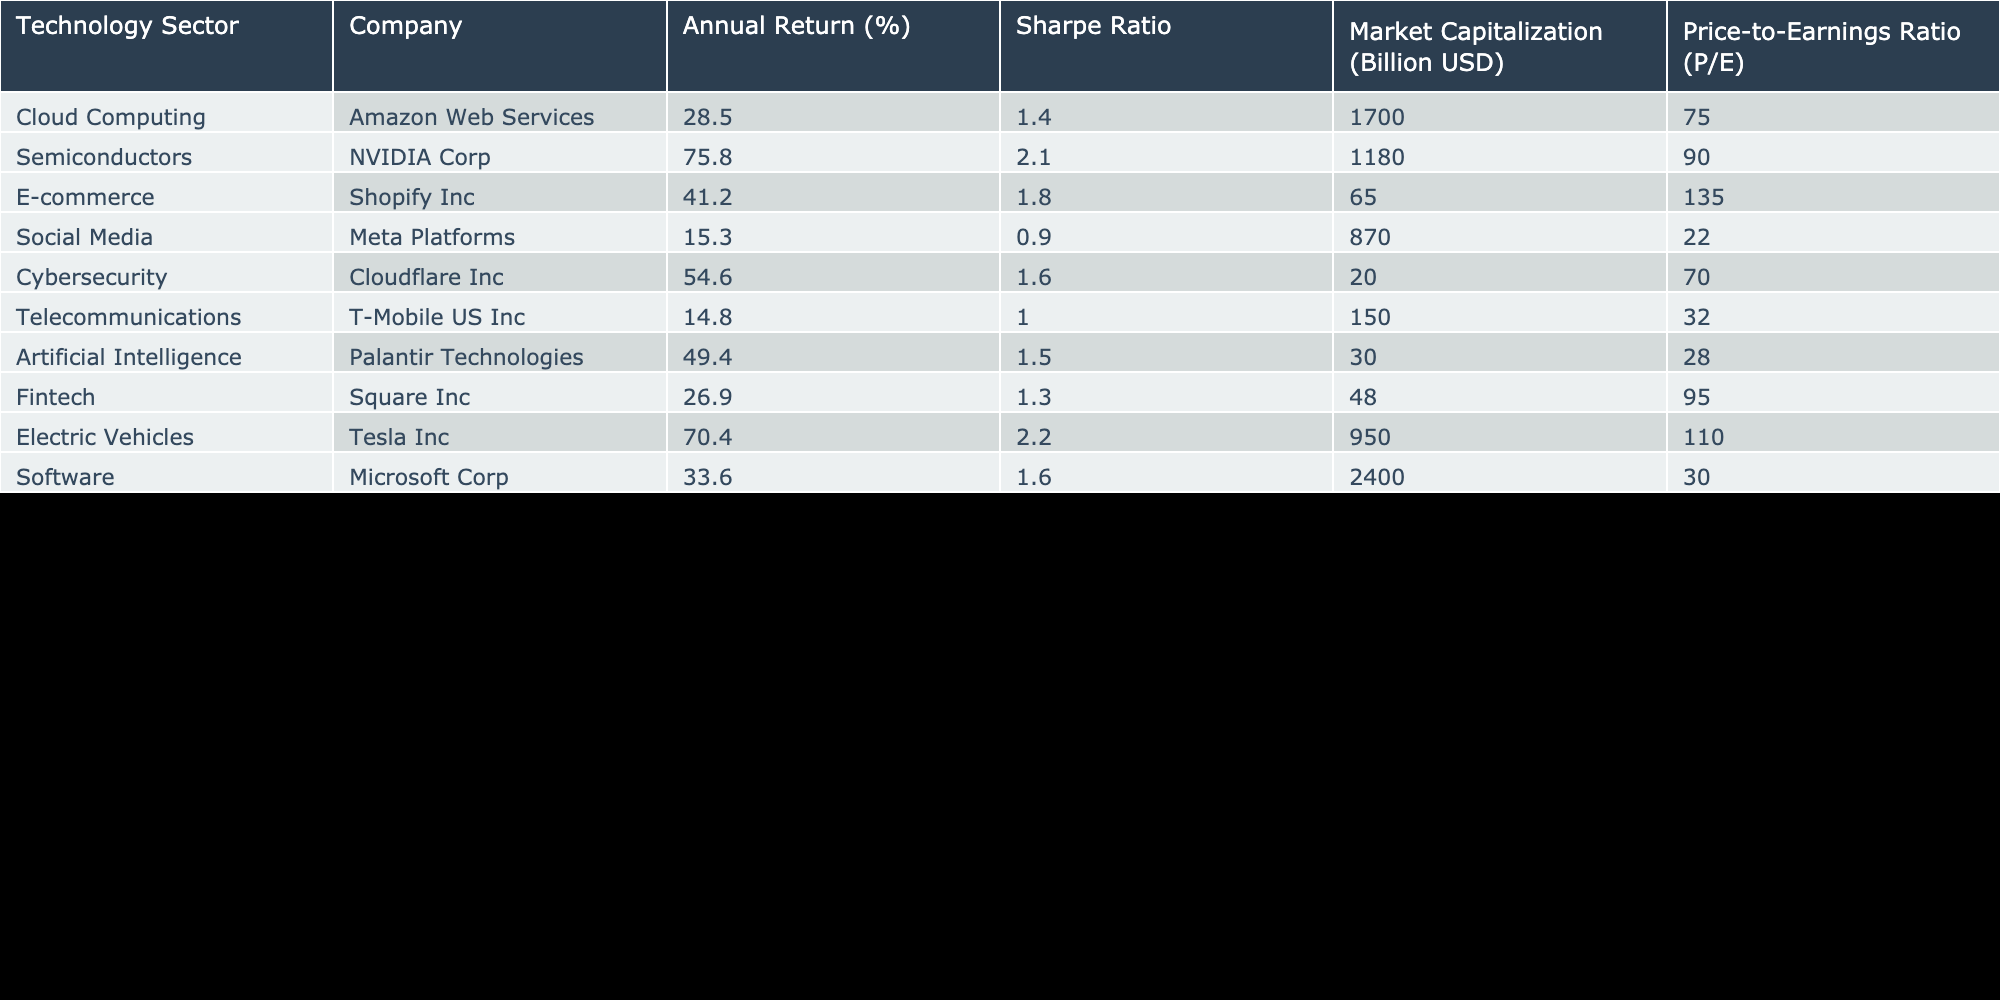What is the annual return percentage for Tesla Inc? The table indicates that Tesla Inc falls under the Electric Vehicles sector, and its annual return is listed as 70.4%.
Answer: 70.4% Which company has the highest Sharpe Ratio? Looking at the Sharpe Ratio column, NVIDIA Corp has the highest value of 2.1.
Answer: NVIDIA Corp What is the average Market Capitalization of the companies listed in the table? To calculate the average, sum the Market Capitalization values: 1700 + 1180 + 65 + 870 + 20 + 150 + 30 + 48 + 950 + 2400 = 5573. Then, divide by the total number of companies (10) to find the average: 5573 / 10 = 557.3 billion USD.
Answer: 557.3 billion USD Does Cloudflare Inc have a higher Price-to-Earnings Ratio than Meta Platforms? Cloudflare Inc has a P/E Ratio of 70 while Meta Platforms has a P/E Ratio of 22. Therefore, Cloudflare Inc does have a higher P/E Ratio.
Answer: Yes What is the difference in annual returns between the highest and lowest performing companies? The highest performing company is NVIDIA Corp with an annual return of 75.8% and the lowest is Meta Platforms with a return of 15.3%. The difference is calculated as 75.8 - 15.3 = 60.5%.
Answer: 60.5% 